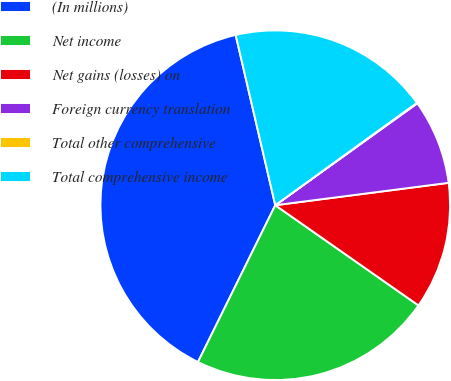Convert chart to OTSL. <chart><loc_0><loc_0><loc_500><loc_500><pie_chart><fcel>(In millions)<fcel>Net income<fcel>Net gains (losses) on<fcel>Foreign currency translation<fcel>Total other comprehensive<fcel>Total comprehensive income<nl><fcel>39.07%<fcel>22.57%<fcel>11.76%<fcel>7.86%<fcel>0.06%<fcel>18.67%<nl></chart> 